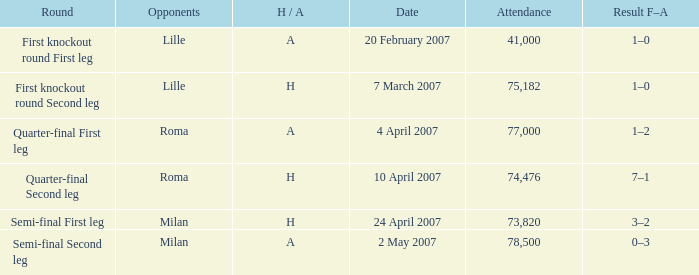How many people attended on 2 may 2007? 78500.0. 